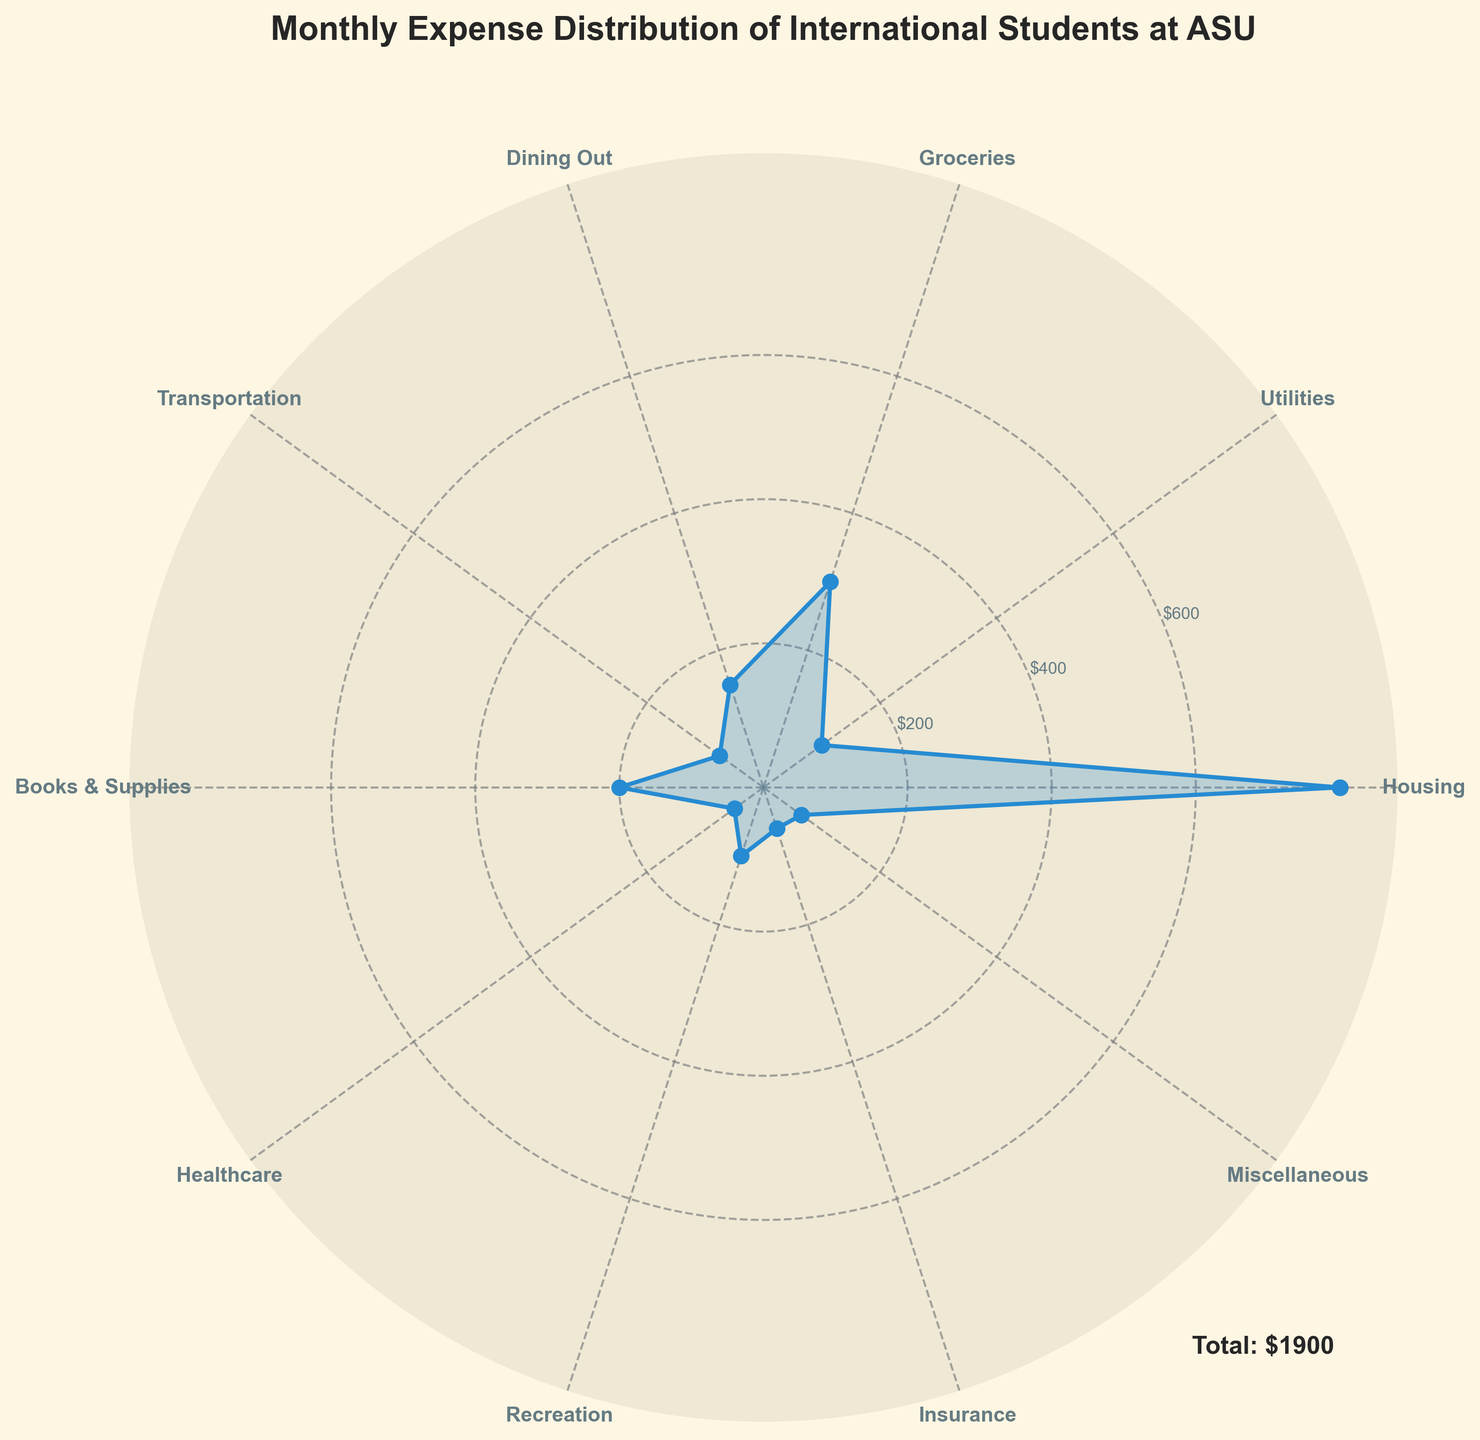What is the title of the chart? The title is usually positioned at the top of the figure and is meant to describe the content in a summarized way. In this figure, it is clearly stated at the top.
Answer: "Monthly Expense Distribution of International Students at ASU" How many categories of expenses are shown in the figure? The categories can be counted by looking at the radial labels or the x-ticks on the polar chart.
Answer: 10 Which category has the highest expense? By inspecting the lengths of the filled areas or the radial axis, the category with the longest radial line represents the highest expense.
Answer: Housing What is the total expense for all categories combined? In the figure, the total expense is stated in the legend-like text usually located near the bottom right of the plot.
Answer: $1900 Which two categories have expenses less than $100? We need to identify the categories with short radial lines and check their corresponding labels.
Answer: Healthcare and Transportation What is the difference between the highest and the second highest expenses? Check the expense value of the highest category (Housing) and the second highest category, then subtract the latter from the former. Housing = $800, Groceries = $300
Answer: $500 How many categories have expenses between $50 and $100? We need to look at the figures that fall within this range and count them.
Answer: 4 Which expense category is placed directly opposite to Groceries in the polar chart? Identify the position of Groceries on the polar plot and find the category located at 180 degrees from it.
Answer: Transportation What is the average expense of the 'Books & Supplies', 'Dining Out', and 'Healthcare' categories? The three values are taken from the radial positions of the noted categories. The values are added together and divided by 3. Books & Supplies = $200, Dining Out = $150, Healthcare = $50; Average = ($200 + $150 + $50)/3
Answer: $133.33 Is the expense for 'Miscellaneous' closer to 'Recreation' or 'Insurance'? Compare the radial lengths of Miscellaneous with those of Recreation and Insurance, and determine which is closer in length. Miscellaneous = $65, Recreation = $100, Insurance = $60
Answer: Insurance 